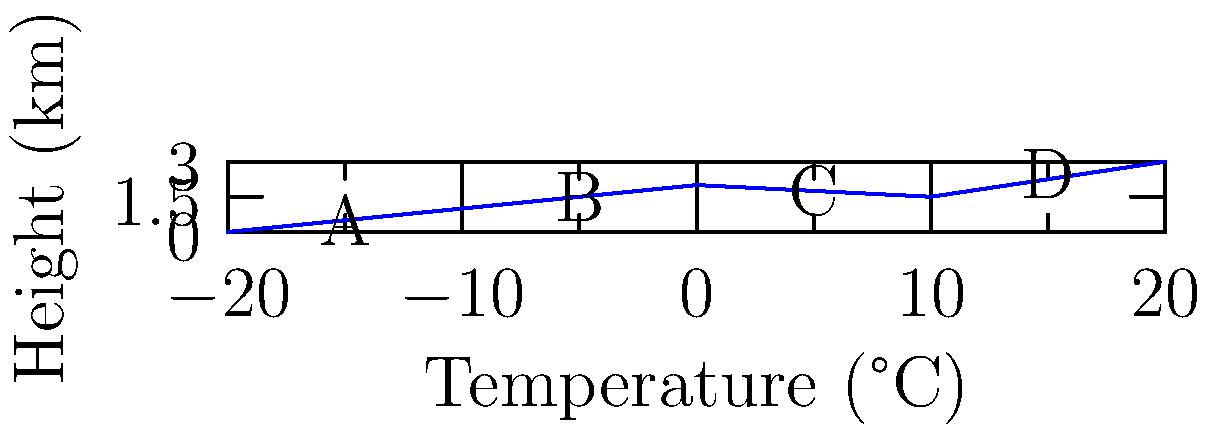In the atmospheric temperature profile shown, which layer represents a temperature inversion? To identify a temperature inversion in this atmospheric temperature profile, we need to analyze the relationship between temperature and height:

1. In a normal atmospheric profile, temperature generally decreases with increasing height (negative lapse rate).

2. A temperature inversion occurs when temperature increases with height (positive lapse rate).

3. Let's examine each layer of the graph:
   - Layer A to B: Temperature increases with height (inversion)
   - Layer B to C: Temperature decreases with height (normal lapse rate)
   - Layer C to D: Temperature increases with height (inversion)

4. Both layers A to B and C to D show temperature inversions. However, the question asks for a single layer.

5. The most pronounced temperature inversion occurs in the layer from A to B, where there is a significant increase in temperature with height.

Therefore, the layer representing a temperature inversion is the one between points A and B.
Answer: Layer A to B 